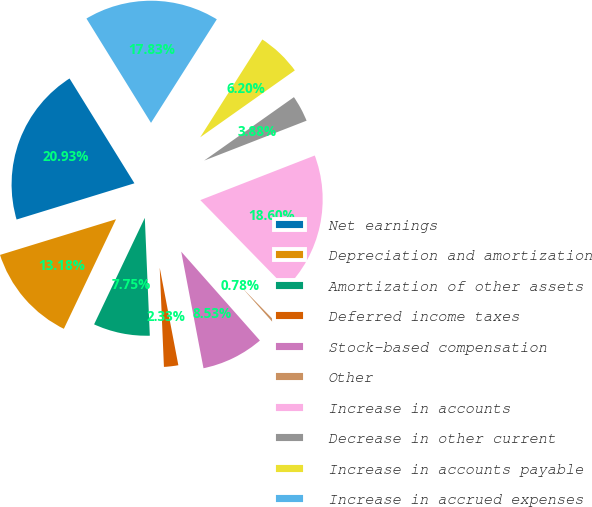Convert chart. <chart><loc_0><loc_0><loc_500><loc_500><pie_chart><fcel>Net earnings<fcel>Depreciation and amortization<fcel>Amortization of other assets<fcel>Deferred income taxes<fcel>Stock-based compensation<fcel>Other<fcel>Increase in accounts<fcel>Decrease in other current<fcel>Increase in accounts payable<fcel>Increase in accrued expenses<nl><fcel>20.93%<fcel>13.18%<fcel>7.75%<fcel>2.33%<fcel>8.53%<fcel>0.78%<fcel>18.6%<fcel>3.88%<fcel>6.2%<fcel>17.83%<nl></chart> 